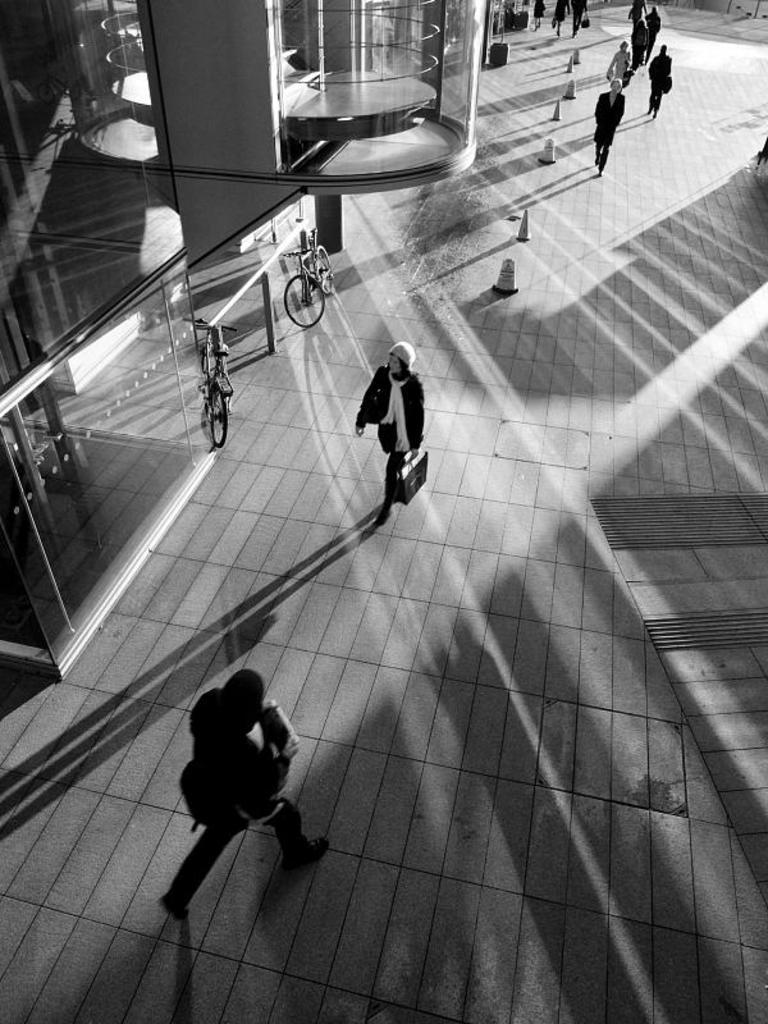What are the people in the image doing? There is a group of people walking in the image. What can be seen on the left side of the image? There is a building and two bicycles on the left side of the image. What type of mine is visible in the image? There is no mine present in the image. Can you tell me how many kitties are walking with the group of people? There are no kitties present in the image; only people are walking. 